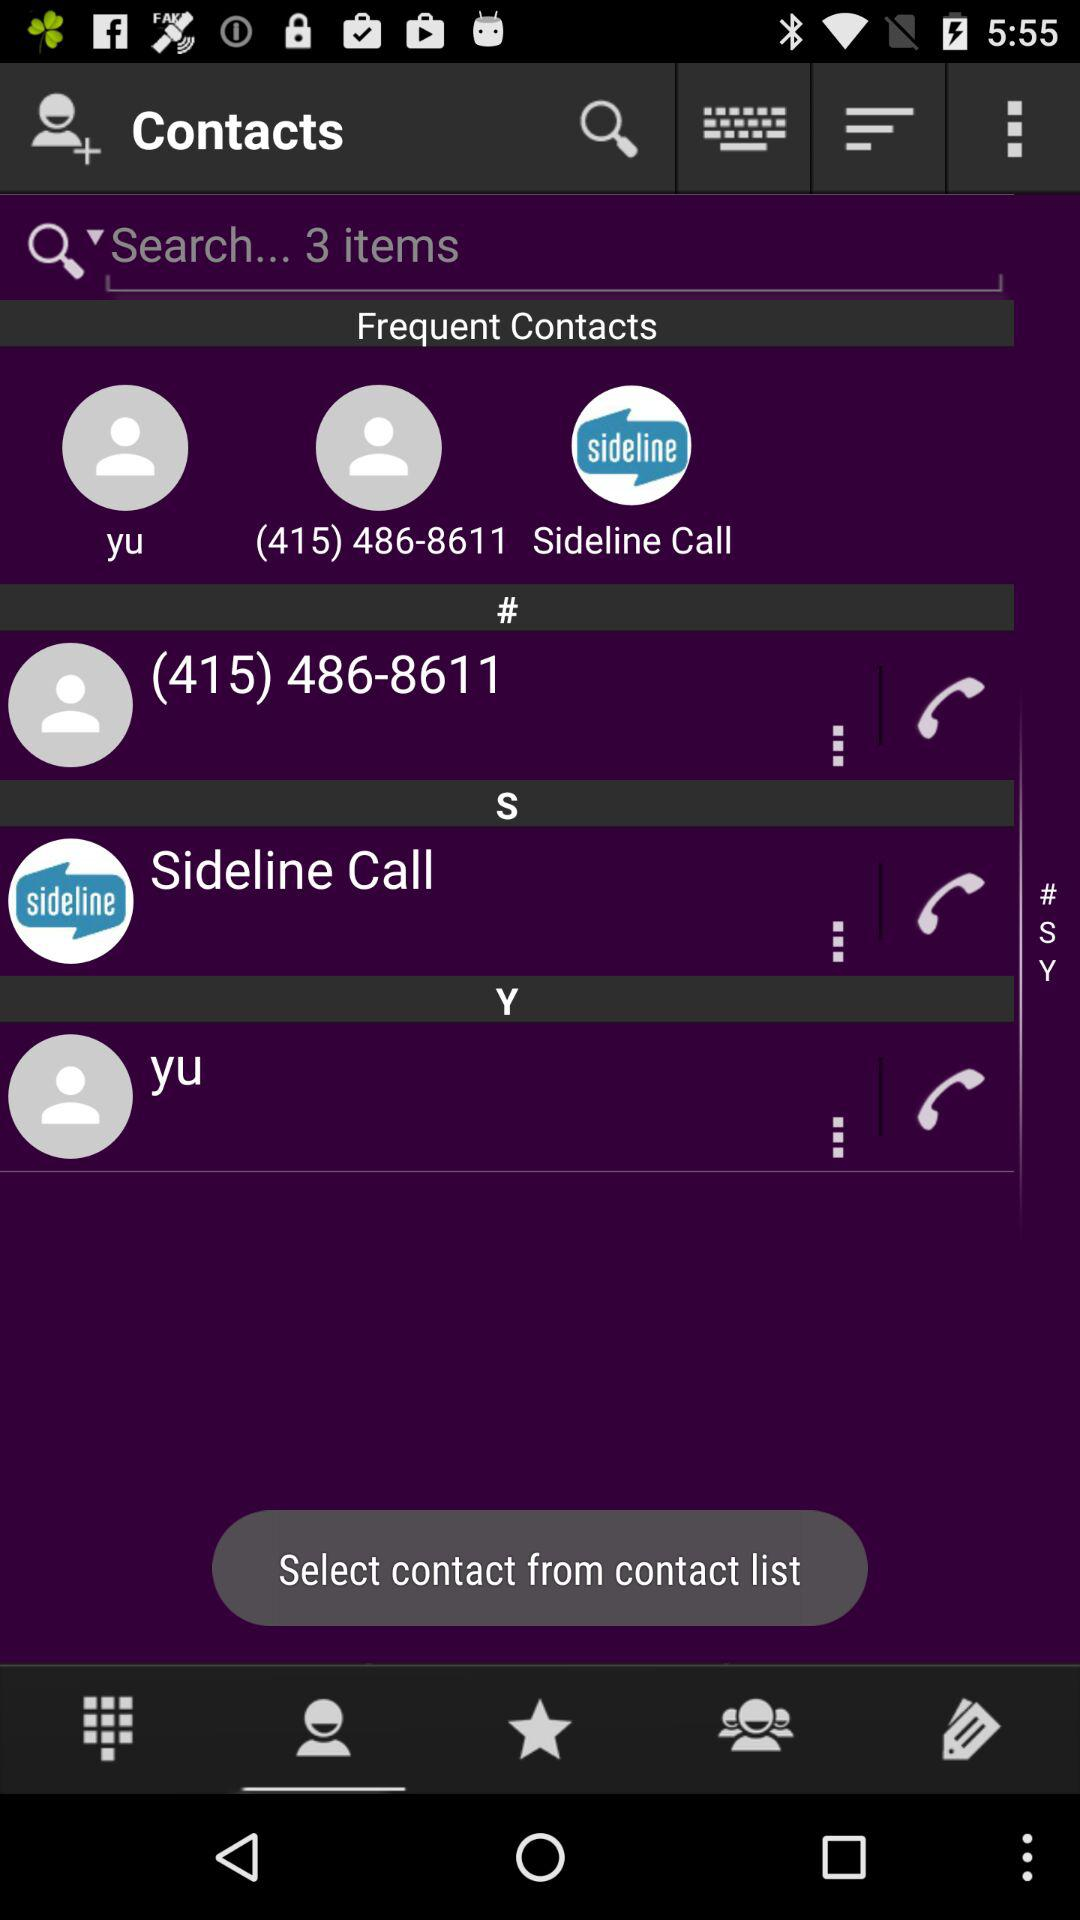How many items are available? There are 3 items available. 